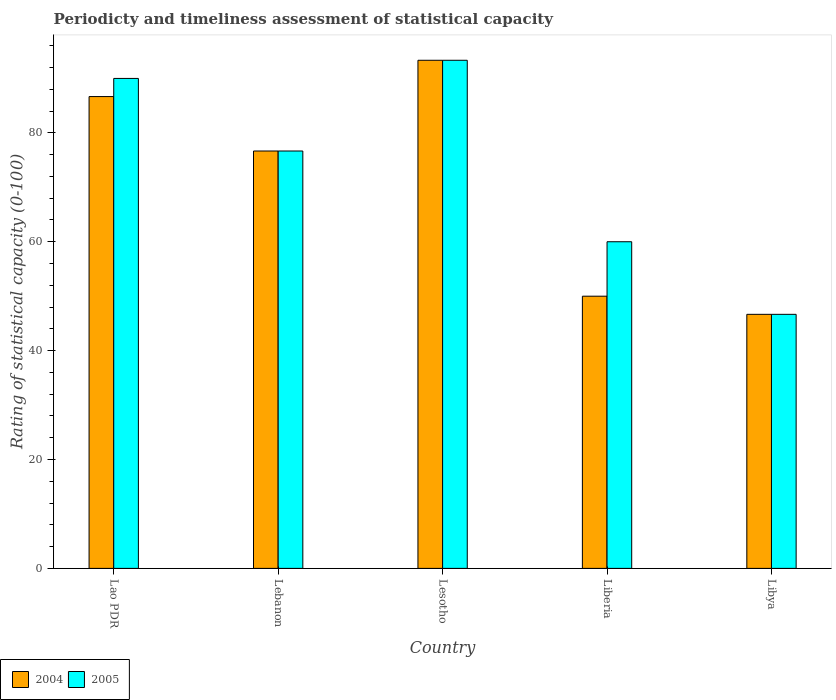What is the label of the 3rd group of bars from the left?
Your answer should be compact. Lesotho. What is the rating of statistical capacity in 2005 in Libya?
Give a very brief answer. 46.67. Across all countries, what is the maximum rating of statistical capacity in 2005?
Your response must be concise. 93.33. Across all countries, what is the minimum rating of statistical capacity in 2004?
Provide a short and direct response. 46.67. In which country was the rating of statistical capacity in 2004 maximum?
Keep it short and to the point. Lesotho. In which country was the rating of statistical capacity in 2004 minimum?
Offer a terse response. Libya. What is the total rating of statistical capacity in 2004 in the graph?
Make the answer very short. 353.33. What is the difference between the rating of statistical capacity in 2004 in Lao PDR and that in Libya?
Provide a succinct answer. 40. What is the difference between the rating of statistical capacity in 2005 in Libya and the rating of statistical capacity in 2004 in Lesotho?
Ensure brevity in your answer.  -46.67. What is the average rating of statistical capacity in 2004 per country?
Make the answer very short. 70.67. What is the difference between the rating of statistical capacity of/in 2005 and rating of statistical capacity of/in 2004 in Lesotho?
Your answer should be very brief. 0. In how many countries, is the rating of statistical capacity in 2005 greater than 16?
Offer a terse response. 5. What is the ratio of the rating of statistical capacity in 2004 in Lebanon to that in Liberia?
Your answer should be compact. 1.53. What is the difference between the highest and the second highest rating of statistical capacity in 2004?
Make the answer very short. -16.67. What is the difference between the highest and the lowest rating of statistical capacity in 2004?
Your answer should be compact. 46.67. In how many countries, is the rating of statistical capacity in 2004 greater than the average rating of statistical capacity in 2004 taken over all countries?
Keep it short and to the point. 3. How many bars are there?
Offer a very short reply. 10. Are all the bars in the graph horizontal?
Your response must be concise. No. What is the difference between two consecutive major ticks on the Y-axis?
Ensure brevity in your answer.  20. Are the values on the major ticks of Y-axis written in scientific E-notation?
Your response must be concise. No. Does the graph contain grids?
Offer a terse response. No. Where does the legend appear in the graph?
Keep it short and to the point. Bottom left. What is the title of the graph?
Your answer should be very brief. Periodicty and timeliness assessment of statistical capacity. Does "2000" appear as one of the legend labels in the graph?
Keep it short and to the point. No. What is the label or title of the Y-axis?
Offer a very short reply. Rating of statistical capacity (0-100). What is the Rating of statistical capacity (0-100) of 2004 in Lao PDR?
Your answer should be compact. 86.67. What is the Rating of statistical capacity (0-100) in 2005 in Lao PDR?
Make the answer very short. 90. What is the Rating of statistical capacity (0-100) in 2004 in Lebanon?
Provide a succinct answer. 76.67. What is the Rating of statistical capacity (0-100) of 2005 in Lebanon?
Give a very brief answer. 76.67. What is the Rating of statistical capacity (0-100) of 2004 in Lesotho?
Ensure brevity in your answer.  93.33. What is the Rating of statistical capacity (0-100) in 2005 in Lesotho?
Offer a very short reply. 93.33. What is the Rating of statistical capacity (0-100) in 2004 in Libya?
Your response must be concise. 46.67. What is the Rating of statistical capacity (0-100) in 2005 in Libya?
Your response must be concise. 46.67. Across all countries, what is the maximum Rating of statistical capacity (0-100) in 2004?
Your answer should be very brief. 93.33. Across all countries, what is the maximum Rating of statistical capacity (0-100) of 2005?
Offer a terse response. 93.33. Across all countries, what is the minimum Rating of statistical capacity (0-100) in 2004?
Provide a short and direct response. 46.67. Across all countries, what is the minimum Rating of statistical capacity (0-100) of 2005?
Keep it short and to the point. 46.67. What is the total Rating of statistical capacity (0-100) in 2004 in the graph?
Offer a terse response. 353.33. What is the total Rating of statistical capacity (0-100) of 2005 in the graph?
Offer a very short reply. 366.67. What is the difference between the Rating of statistical capacity (0-100) in 2005 in Lao PDR and that in Lebanon?
Provide a short and direct response. 13.33. What is the difference between the Rating of statistical capacity (0-100) of 2004 in Lao PDR and that in Lesotho?
Your answer should be compact. -6.67. What is the difference between the Rating of statistical capacity (0-100) of 2005 in Lao PDR and that in Lesotho?
Provide a short and direct response. -3.33. What is the difference between the Rating of statistical capacity (0-100) of 2004 in Lao PDR and that in Liberia?
Your response must be concise. 36.67. What is the difference between the Rating of statistical capacity (0-100) in 2004 in Lao PDR and that in Libya?
Make the answer very short. 40. What is the difference between the Rating of statistical capacity (0-100) in 2005 in Lao PDR and that in Libya?
Make the answer very short. 43.33. What is the difference between the Rating of statistical capacity (0-100) in 2004 in Lebanon and that in Lesotho?
Give a very brief answer. -16.67. What is the difference between the Rating of statistical capacity (0-100) of 2005 in Lebanon and that in Lesotho?
Your response must be concise. -16.67. What is the difference between the Rating of statistical capacity (0-100) of 2004 in Lebanon and that in Liberia?
Give a very brief answer. 26.67. What is the difference between the Rating of statistical capacity (0-100) in 2005 in Lebanon and that in Liberia?
Offer a terse response. 16.67. What is the difference between the Rating of statistical capacity (0-100) of 2004 in Lesotho and that in Liberia?
Provide a succinct answer. 43.33. What is the difference between the Rating of statistical capacity (0-100) of 2005 in Lesotho and that in Liberia?
Your response must be concise. 33.33. What is the difference between the Rating of statistical capacity (0-100) in 2004 in Lesotho and that in Libya?
Your answer should be compact. 46.67. What is the difference between the Rating of statistical capacity (0-100) of 2005 in Lesotho and that in Libya?
Provide a short and direct response. 46.67. What is the difference between the Rating of statistical capacity (0-100) of 2005 in Liberia and that in Libya?
Provide a succinct answer. 13.33. What is the difference between the Rating of statistical capacity (0-100) in 2004 in Lao PDR and the Rating of statistical capacity (0-100) in 2005 in Lebanon?
Offer a very short reply. 10. What is the difference between the Rating of statistical capacity (0-100) of 2004 in Lao PDR and the Rating of statistical capacity (0-100) of 2005 in Lesotho?
Your answer should be very brief. -6.67. What is the difference between the Rating of statistical capacity (0-100) of 2004 in Lao PDR and the Rating of statistical capacity (0-100) of 2005 in Liberia?
Give a very brief answer. 26.67. What is the difference between the Rating of statistical capacity (0-100) in 2004 in Lebanon and the Rating of statistical capacity (0-100) in 2005 in Lesotho?
Give a very brief answer. -16.67. What is the difference between the Rating of statistical capacity (0-100) in 2004 in Lebanon and the Rating of statistical capacity (0-100) in 2005 in Liberia?
Give a very brief answer. 16.67. What is the difference between the Rating of statistical capacity (0-100) of 2004 in Lesotho and the Rating of statistical capacity (0-100) of 2005 in Liberia?
Your answer should be very brief. 33.33. What is the difference between the Rating of statistical capacity (0-100) in 2004 in Lesotho and the Rating of statistical capacity (0-100) in 2005 in Libya?
Ensure brevity in your answer.  46.67. What is the average Rating of statistical capacity (0-100) of 2004 per country?
Your answer should be compact. 70.67. What is the average Rating of statistical capacity (0-100) of 2005 per country?
Give a very brief answer. 73.33. What is the difference between the Rating of statistical capacity (0-100) in 2004 and Rating of statistical capacity (0-100) in 2005 in Lao PDR?
Your answer should be compact. -3.33. What is the difference between the Rating of statistical capacity (0-100) in 2004 and Rating of statistical capacity (0-100) in 2005 in Libya?
Your answer should be very brief. 0. What is the ratio of the Rating of statistical capacity (0-100) in 2004 in Lao PDR to that in Lebanon?
Ensure brevity in your answer.  1.13. What is the ratio of the Rating of statistical capacity (0-100) in 2005 in Lao PDR to that in Lebanon?
Keep it short and to the point. 1.17. What is the ratio of the Rating of statistical capacity (0-100) of 2005 in Lao PDR to that in Lesotho?
Ensure brevity in your answer.  0.96. What is the ratio of the Rating of statistical capacity (0-100) in 2004 in Lao PDR to that in Liberia?
Make the answer very short. 1.73. What is the ratio of the Rating of statistical capacity (0-100) of 2004 in Lao PDR to that in Libya?
Ensure brevity in your answer.  1.86. What is the ratio of the Rating of statistical capacity (0-100) of 2005 in Lao PDR to that in Libya?
Keep it short and to the point. 1.93. What is the ratio of the Rating of statistical capacity (0-100) in 2004 in Lebanon to that in Lesotho?
Your answer should be very brief. 0.82. What is the ratio of the Rating of statistical capacity (0-100) of 2005 in Lebanon to that in Lesotho?
Make the answer very short. 0.82. What is the ratio of the Rating of statistical capacity (0-100) of 2004 in Lebanon to that in Liberia?
Your answer should be compact. 1.53. What is the ratio of the Rating of statistical capacity (0-100) in 2005 in Lebanon to that in Liberia?
Keep it short and to the point. 1.28. What is the ratio of the Rating of statistical capacity (0-100) in 2004 in Lebanon to that in Libya?
Give a very brief answer. 1.64. What is the ratio of the Rating of statistical capacity (0-100) in 2005 in Lebanon to that in Libya?
Your response must be concise. 1.64. What is the ratio of the Rating of statistical capacity (0-100) of 2004 in Lesotho to that in Liberia?
Ensure brevity in your answer.  1.87. What is the ratio of the Rating of statistical capacity (0-100) of 2005 in Lesotho to that in Liberia?
Provide a succinct answer. 1.56. What is the ratio of the Rating of statistical capacity (0-100) in 2004 in Lesotho to that in Libya?
Provide a short and direct response. 2. What is the ratio of the Rating of statistical capacity (0-100) in 2005 in Lesotho to that in Libya?
Your response must be concise. 2. What is the ratio of the Rating of statistical capacity (0-100) in 2004 in Liberia to that in Libya?
Give a very brief answer. 1.07. What is the ratio of the Rating of statistical capacity (0-100) of 2005 in Liberia to that in Libya?
Your answer should be compact. 1.29. What is the difference between the highest and the lowest Rating of statistical capacity (0-100) in 2004?
Provide a short and direct response. 46.67. What is the difference between the highest and the lowest Rating of statistical capacity (0-100) in 2005?
Make the answer very short. 46.67. 